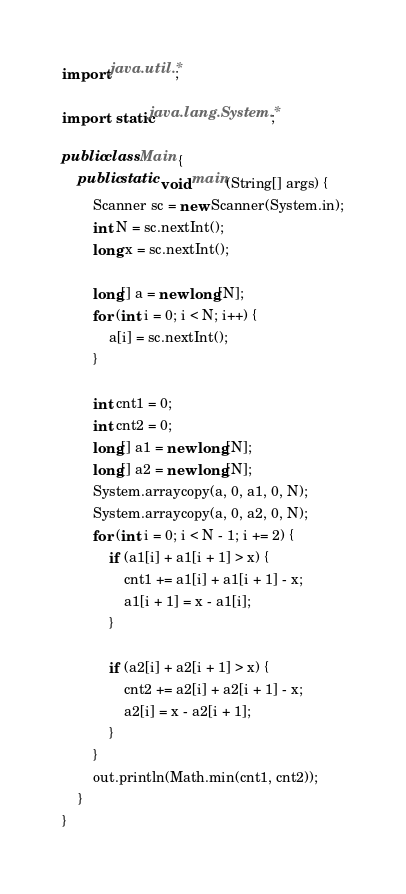Convert code to text. <code><loc_0><loc_0><loc_500><loc_500><_Java_>import java.util.*;

import static java.lang.System.*;

public class Main {
    public static void main(String[] args) {
        Scanner sc = new Scanner(System.in);
        int N = sc.nextInt();
        long x = sc.nextInt();

        long[] a = new long[N];
        for (int i = 0; i < N; i++) {
            a[i] = sc.nextInt();
        }

        int cnt1 = 0;
        int cnt2 = 0;
        long[] a1 = new long[N];
        long[] a2 = new long[N];
        System.arraycopy(a, 0, a1, 0, N);
        System.arraycopy(a, 0, a2, 0, N);
        for (int i = 0; i < N - 1; i += 2) {
            if (a1[i] + a1[i + 1] > x) {
                cnt1 += a1[i] + a1[i + 1] - x;
                a1[i + 1] = x - a1[i];
            }

            if (a2[i] + a2[i + 1] > x) {
                cnt2 += a2[i] + a2[i + 1] - x;
                a2[i] = x - a2[i + 1];
            }
        }
        out.println(Math.min(cnt1, cnt2));
    }
}</code> 